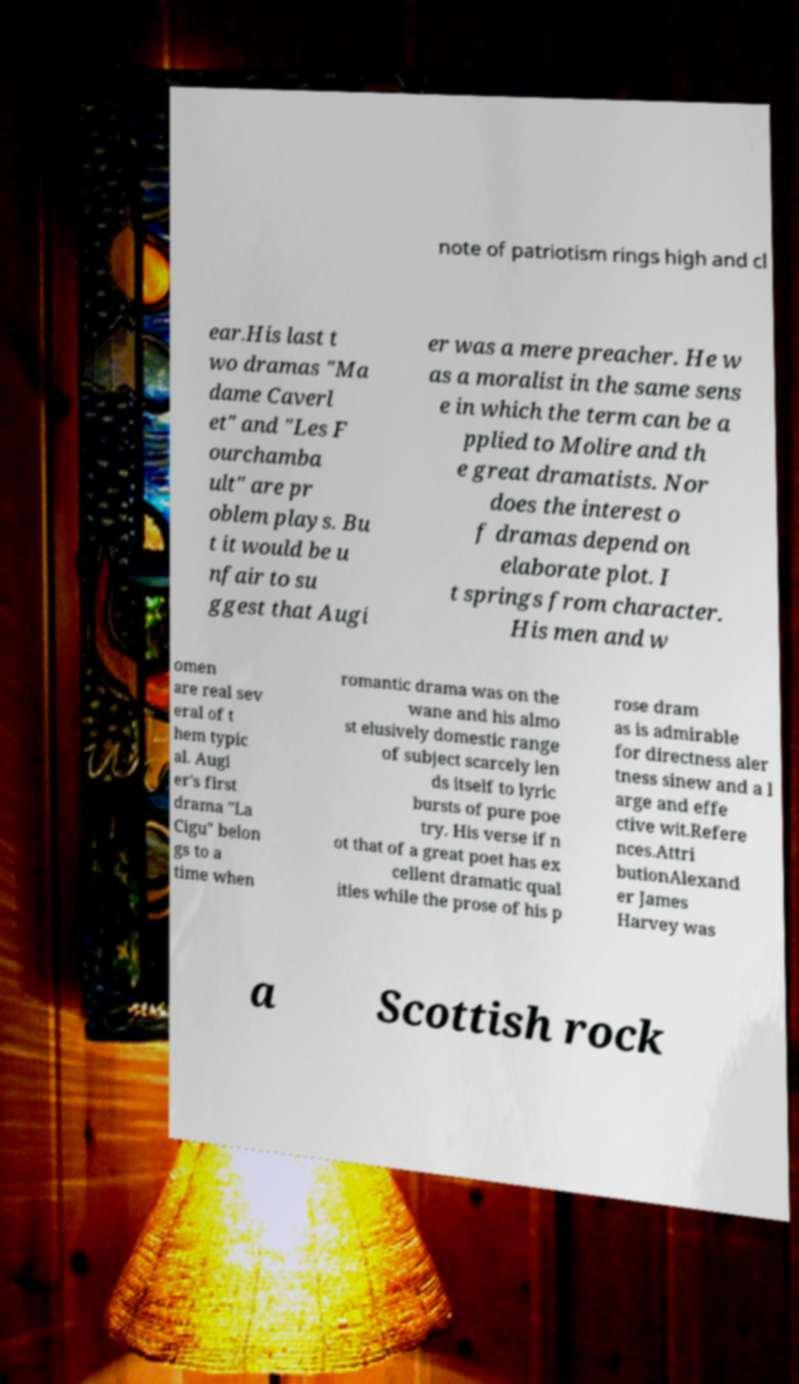There's text embedded in this image that I need extracted. Can you transcribe it verbatim? note of patriotism rings high and cl ear.His last t wo dramas "Ma dame Caverl et" and "Les F ourchamba ult" are pr oblem plays. Bu t it would be u nfair to su ggest that Augi er was a mere preacher. He w as a moralist in the same sens e in which the term can be a pplied to Molire and th e great dramatists. Nor does the interest o f dramas depend on elaborate plot. I t springs from character. His men and w omen are real sev eral of t hem typic al. Augi er's first drama "La Cigu" belon gs to a time when romantic drama was on the wane and his almo st elusively domestic range of subject scarcely len ds itself to lyric bursts of pure poe try. His verse if n ot that of a great poet has ex cellent dramatic qual ities while the prose of his p rose dram as is admirable for directness aler tness sinew and a l arge and effe ctive wit.Refere nces.Attri butionAlexand er James Harvey was a Scottish rock 